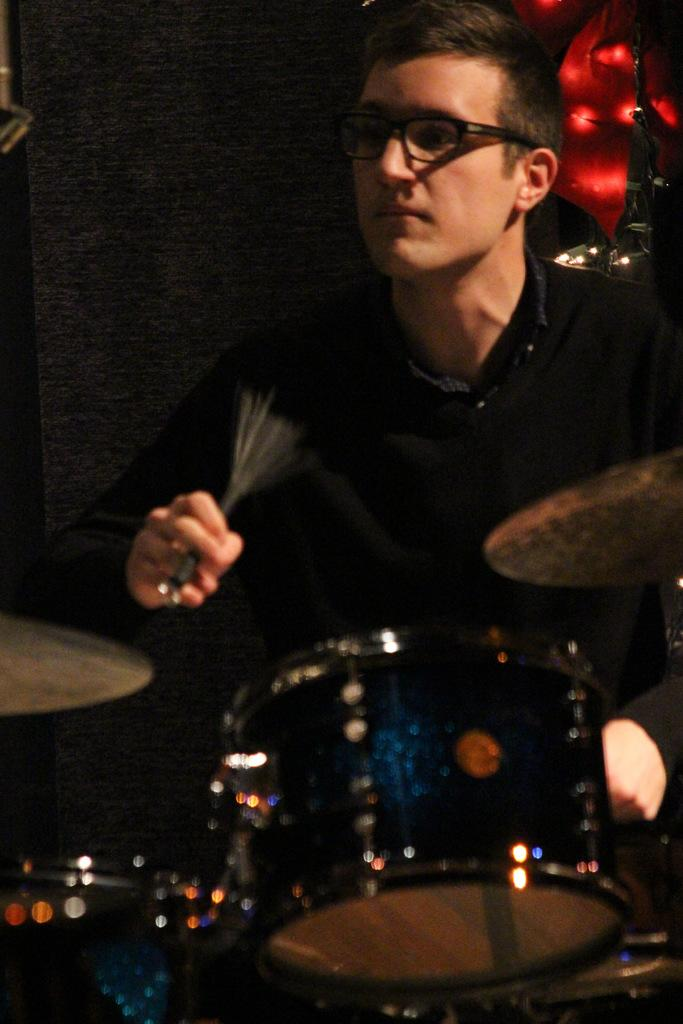Who is present in the image? There is a man in the image. What is the man doing in the image? The man is holding objects in his hands. What type of objects is the man holding? The objects are drums, which are musical instruments. What can be observed about the background of the image? The background of the image is dark. How many crates are stacked behind the man in the image? There are no crates visible in the image. Can you describe the man's breathing pattern in the image? The image does not provide any information about the man's breathing pattern. 